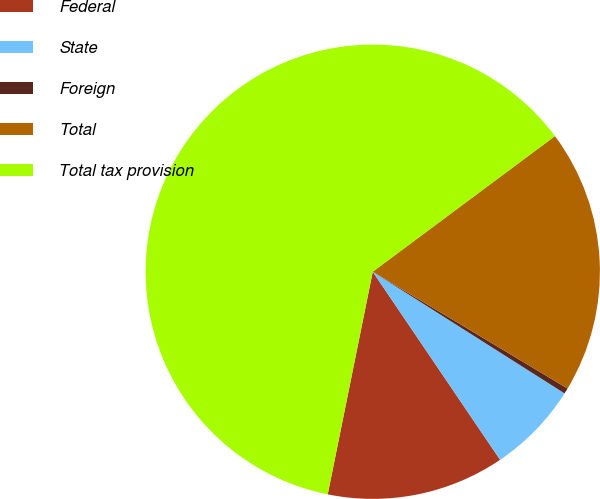<chart> <loc_0><loc_0><loc_500><loc_500><pie_chart><fcel>Federal<fcel>State<fcel>Foreign<fcel>Total<fcel>Total tax provision<nl><fcel>12.65%<fcel>6.53%<fcel>0.4%<fcel>18.78%<fcel>61.64%<nl></chart> 